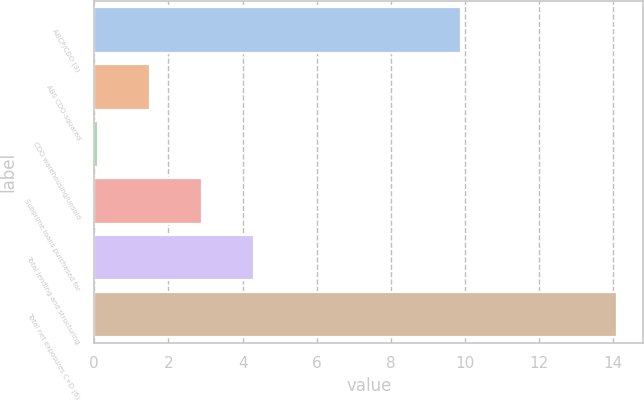Convert chart to OTSL. <chart><loc_0><loc_0><loc_500><loc_500><bar_chart><fcel>ABCP/CDO (3)<fcel>ABS CDO-squared<fcel>CDO warehousing/unsold<fcel>Subprime loans purchased for<fcel>Total lending and structuring<fcel>Total net exposures C+D (6)<nl><fcel>9.9<fcel>1.5<fcel>0.1<fcel>2.9<fcel>4.3<fcel>14.1<nl></chart> 